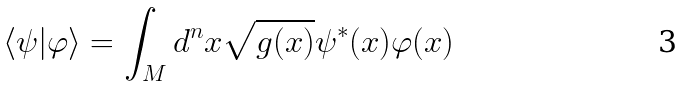<formula> <loc_0><loc_0><loc_500><loc_500>\langle \psi | \varphi \rangle = \int _ { M } d ^ { n } x \sqrt { g ( x ) } \psi ^ { \ast } ( x ) \varphi ( x )</formula> 